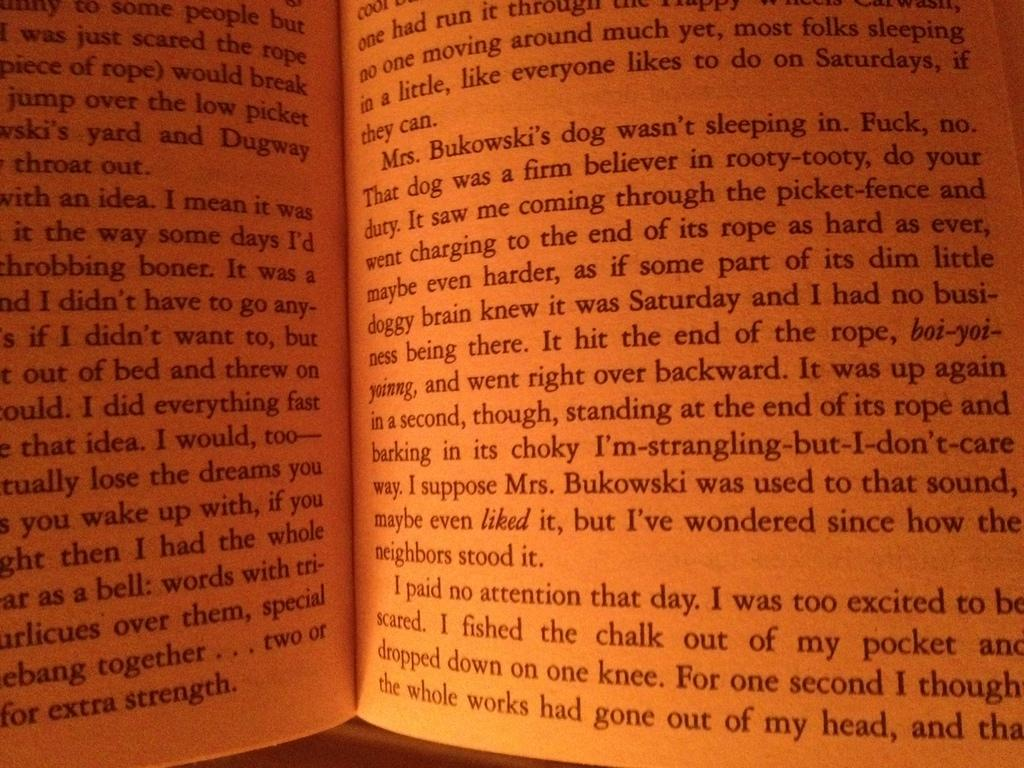<image>
Share a concise interpretation of the image provided. A book is opened to a page describing a character by the name of Mrs. Bukowski. 